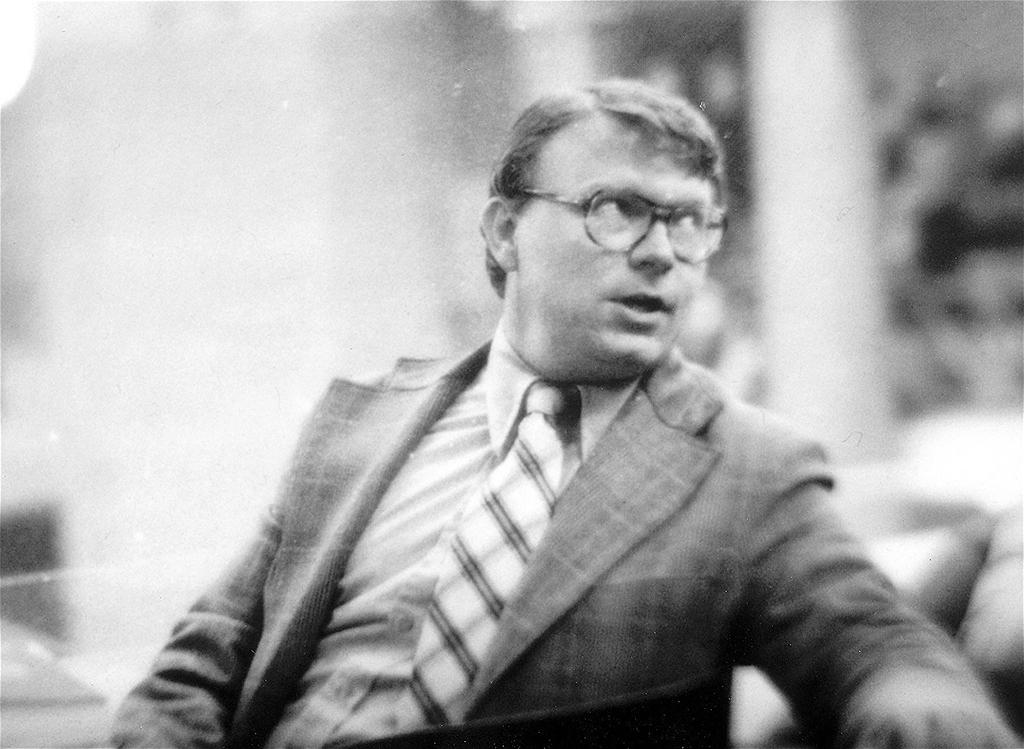What is the main subject of the image? There is a man sitting in the image. Can you describe the background of the image? The background of the image is blurry. What color scheme is used in the image? The image is in black and white color. What is the man doing in the image that involves a leg and a surprise? There is no mention of a leg or a surprise in the image, so we cannot answer that question. 